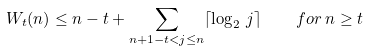Convert formula to latex. <formula><loc_0><loc_0><loc_500><loc_500>W _ { t } ( n ) \leq n - t + \sum _ { n + 1 - t < j \leq n } \lceil { \log _ { 2 } \, j } \rceil \quad f o r \, n \geq t</formula> 